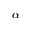Convert formula to latex. <formula><loc_0><loc_0><loc_500><loc_500>\boldsymbol \alpha</formula> 